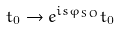Convert formula to latex. <formula><loc_0><loc_0><loc_500><loc_500>t _ { 0 } \rightarrow e ^ { i s \varphi _ { S O } } t _ { 0 }</formula> 